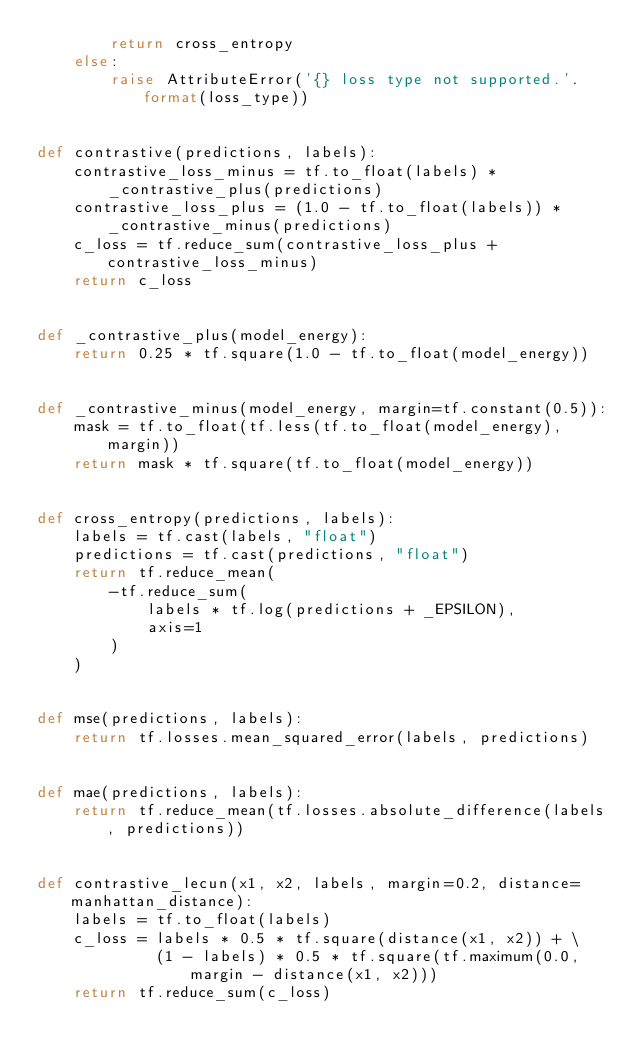<code> <loc_0><loc_0><loc_500><loc_500><_Python_>        return cross_entropy
    else:
        raise AttributeError('{} loss type not supported.'.format(loss_type))


def contrastive(predictions, labels):
    contrastive_loss_minus = tf.to_float(labels) * _contrastive_plus(predictions)
    contrastive_loss_plus = (1.0 - tf.to_float(labels)) * _contrastive_minus(predictions)
    c_loss = tf.reduce_sum(contrastive_loss_plus + contrastive_loss_minus)
    return c_loss


def _contrastive_plus(model_energy):
    return 0.25 * tf.square(1.0 - tf.to_float(model_energy))


def _contrastive_minus(model_energy, margin=tf.constant(0.5)):
    mask = tf.to_float(tf.less(tf.to_float(model_energy), margin))
    return mask * tf.square(tf.to_float(model_energy))


def cross_entropy(predictions, labels):
    labels = tf.cast(labels, "float")
    predictions = tf.cast(predictions, "float")
    return tf.reduce_mean(
        -tf.reduce_sum(
            labels * tf.log(predictions + _EPSILON),
            axis=1
        )
    )


def mse(predictions, labels):
    return tf.losses.mean_squared_error(labels, predictions)


def mae(predictions, labels):
    return tf.reduce_mean(tf.losses.absolute_difference(labels, predictions))


def contrastive_lecun(x1, x2, labels, margin=0.2, distance=manhattan_distance):
    labels = tf.to_float(labels)
    c_loss = labels * 0.5 * tf.square(distance(x1, x2)) + \
             (1 - labels) * 0.5 * tf.square(tf.maximum(0.0, margin - distance(x1, x2)))
    return tf.reduce_sum(c_loss)
</code> 